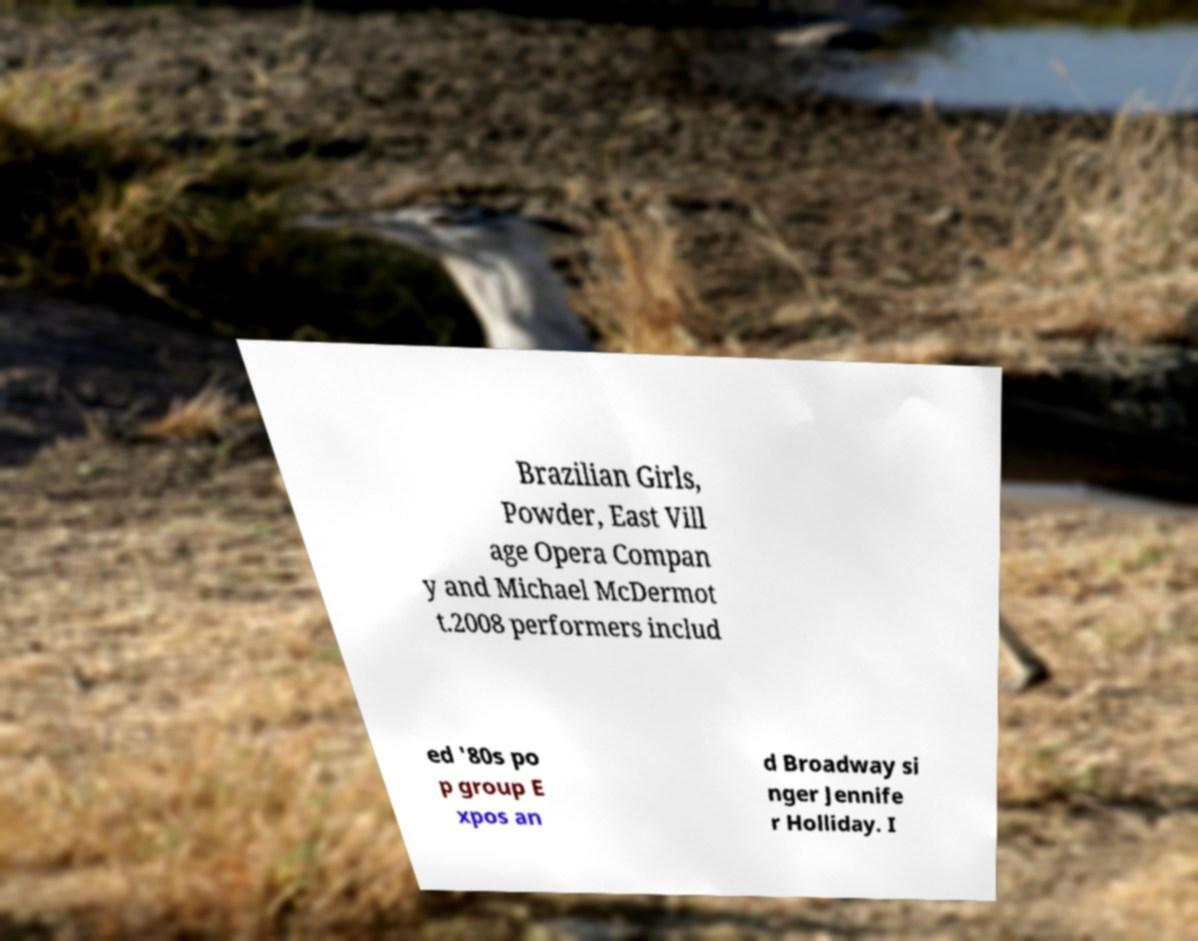Please read and relay the text visible in this image. What does it say? Brazilian Girls, Powder, East Vill age Opera Compan y and Michael McDermot t.2008 performers includ ed '80s po p group E xpos an d Broadway si nger Jennife r Holliday. I 